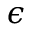Convert formula to latex. <formula><loc_0><loc_0><loc_500><loc_500>\epsilon</formula> 